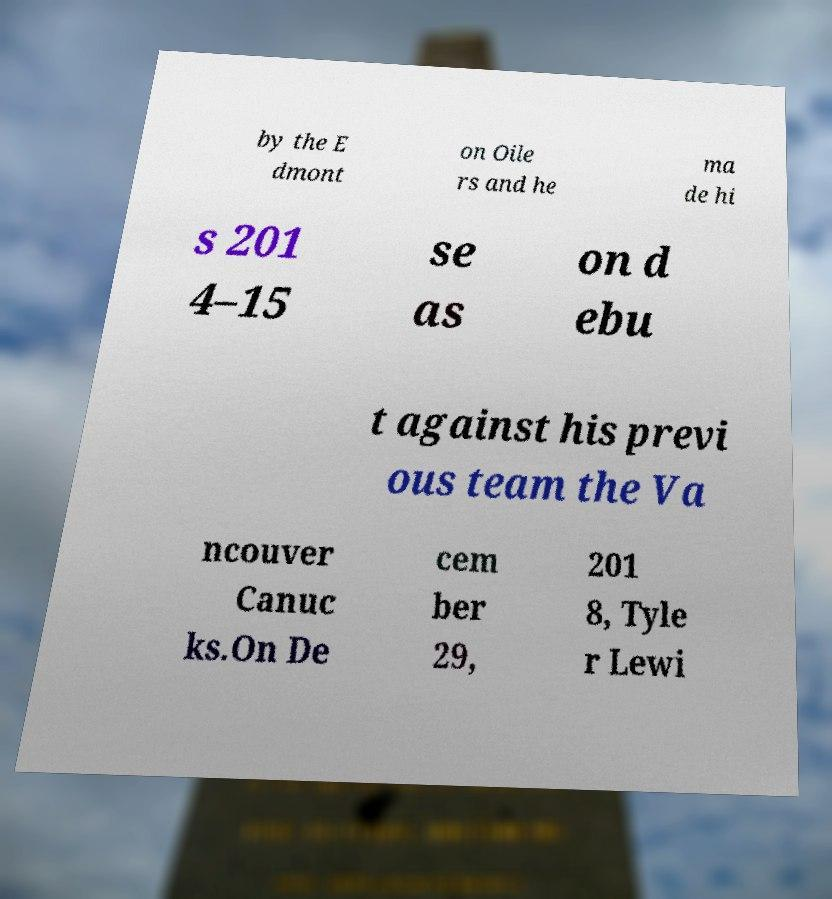What messages or text are displayed in this image? I need them in a readable, typed format. by the E dmont on Oile rs and he ma de hi s 201 4–15 se as on d ebu t against his previ ous team the Va ncouver Canuc ks.On De cem ber 29, 201 8, Tyle r Lewi 